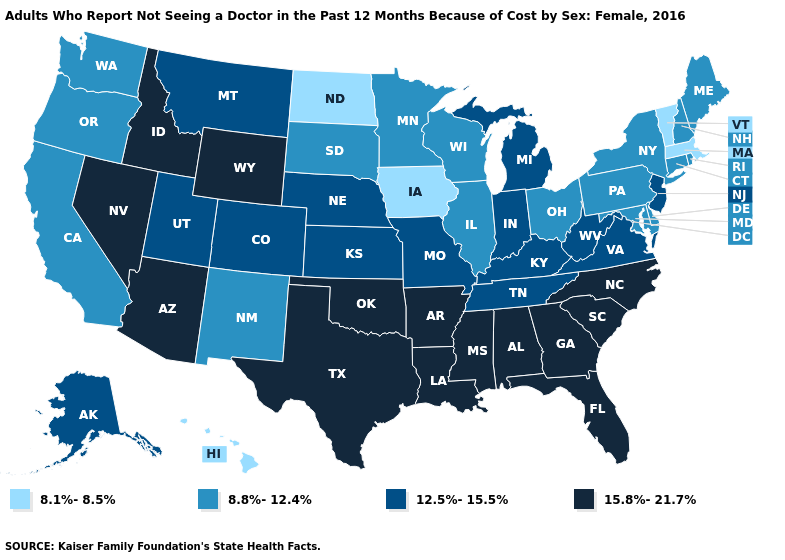Which states have the lowest value in the West?
Give a very brief answer. Hawaii. Name the states that have a value in the range 12.5%-15.5%?
Short answer required. Alaska, Colorado, Indiana, Kansas, Kentucky, Michigan, Missouri, Montana, Nebraska, New Jersey, Tennessee, Utah, Virginia, West Virginia. Does Wisconsin have the same value as Washington?
Concise answer only. Yes. Is the legend a continuous bar?
Concise answer only. No. Does Georgia have a lower value than Michigan?
Answer briefly. No. Which states have the lowest value in the USA?
Be succinct. Hawaii, Iowa, Massachusetts, North Dakota, Vermont. Among the states that border Idaho , does Oregon have the lowest value?
Write a very short answer. Yes. What is the lowest value in the USA?
Quick response, please. 8.1%-8.5%. Among the states that border California , does Nevada have the lowest value?
Write a very short answer. No. What is the highest value in states that border West Virginia?
Keep it brief. 12.5%-15.5%. What is the value of South Dakota?
Keep it brief. 8.8%-12.4%. Among the states that border North Dakota , does Montana have the lowest value?
Short answer required. No. Which states have the lowest value in the USA?
Concise answer only. Hawaii, Iowa, Massachusetts, North Dakota, Vermont. Does Idaho have the highest value in the West?
Short answer required. Yes. 